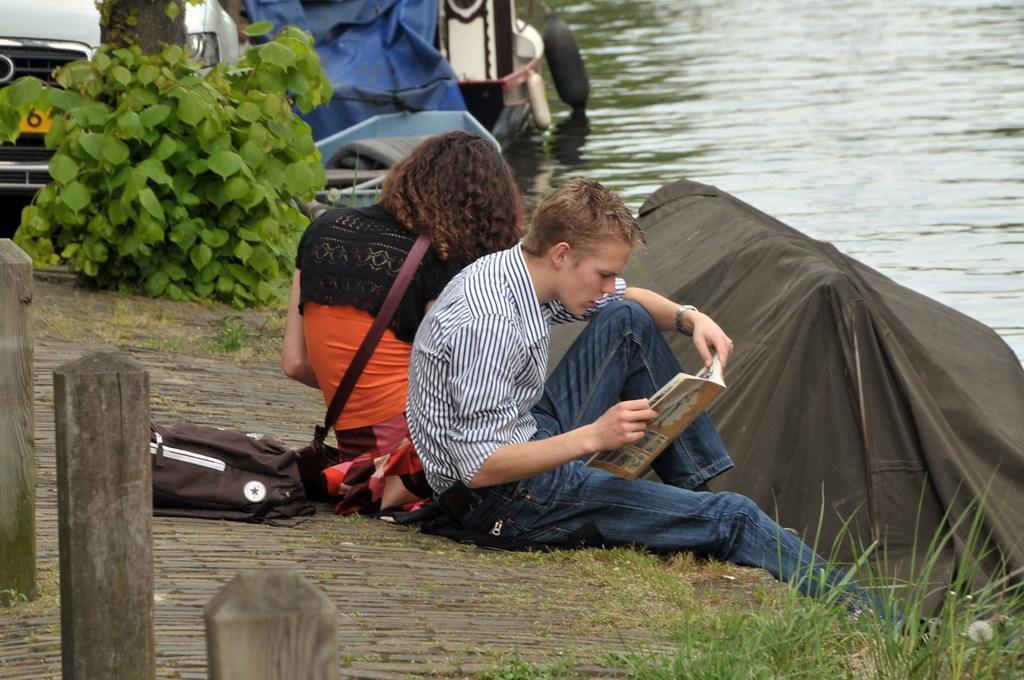Can you describe this image briefly? In this picture we can see a bag, book and two people sitting on a platform, plants, car and in the background we can see boats on water. 